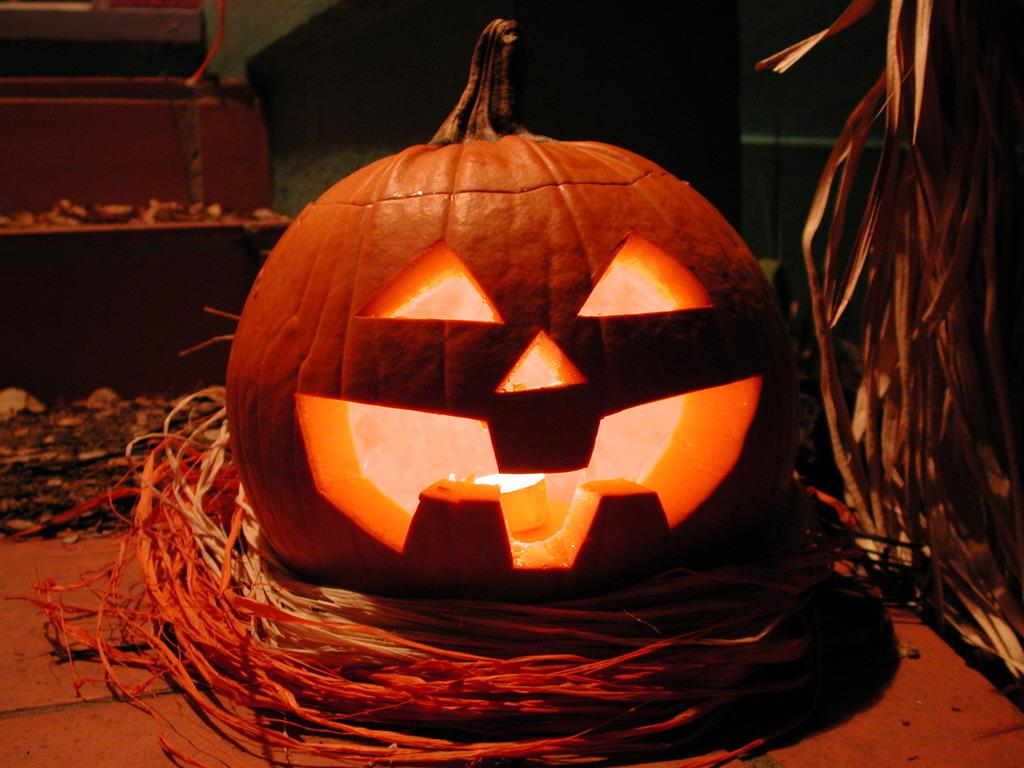What activity is being performed in the image? There is a pumpkin being carved in the image. What type of vegetation is present in the image? There is dried grass in the image. How would you describe the lighting in the image? The background of the image is dark. What can be seen in the background of the image? There are visible objects in the background of the image. How many tickets are needed to begin the bath in the image? There is no mention of tickets or a bath in the image; it features a pumpkin being carved and dried grass. 